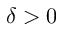Convert formula to latex. <formula><loc_0><loc_0><loc_500><loc_500>\delta > 0</formula> 